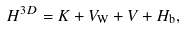<formula> <loc_0><loc_0><loc_500><loc_500>H ^ { 3 D } = K + V _ { \text {W} } + V + H _ { \text {b} } ,</formula> 